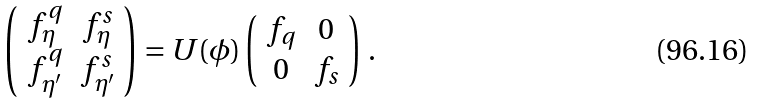Convert formula to latex. <formula><loc_0><loc_0><loc_500><loc_500>\left ( \begin{array} { c c } f _ { \eta } ^ { q } & f _ { \eta } ^ { s } \\ f _ { \eta ^ { \prime } } ^ { q } & f _ { \eta ^ { \prime } } ^ { s } \\ \end{array} \right ) = U ( \phi ) \left ( \begin{array} { c c } f _ { q } & 0 \\ 0 & f _ { s } \\ \end{array} \right ) \, .</formula> 